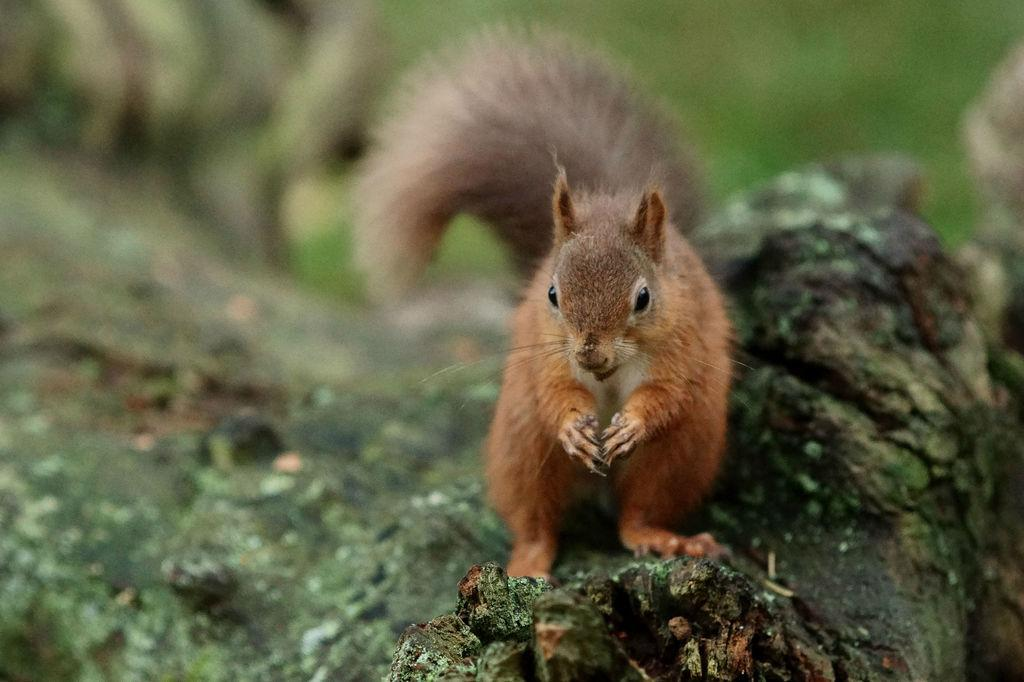What animal is present in the image? There is a squirrel in the image. Where is the squirrel located? The squirrel is on a branch. Can you describe the background of the image? The background of the image is blurred. What type of bead is hanging from the branch in the image? There is no bead present in the image; it features a squirrel on a branch with a blurred background. 